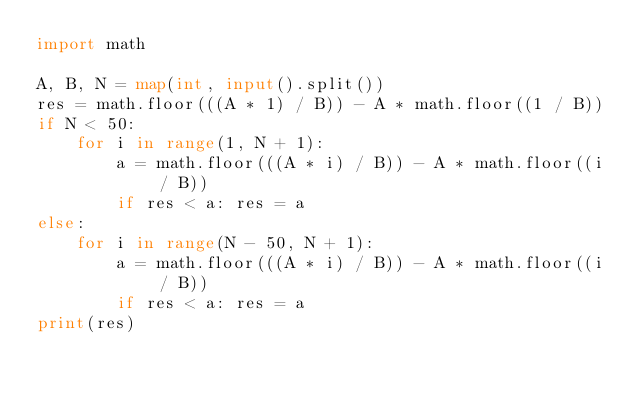<code> <loc_0><loc_0><loc_500><loc_500><_Python_>import math

A, B, N = map(int, input().split())
res = math.floor(((A * 1) / B)) - A * math.floor((1 / B))
if N < 50:
    for i in range(1, N + 1):
        a = math.floor(((A * i) / B)) - A * math.floor((i / B))
        if res < a: res = a
else:
    for i in range(N - 50, N + 1):
        a = math.floor(((A * i) / B)) - A * math.floor((i / B))
        if res < a: res = a
print(res)</code> 